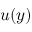<formula> <loc_0><loc_0><loc_500><loc_500>u ( y )</formula> 